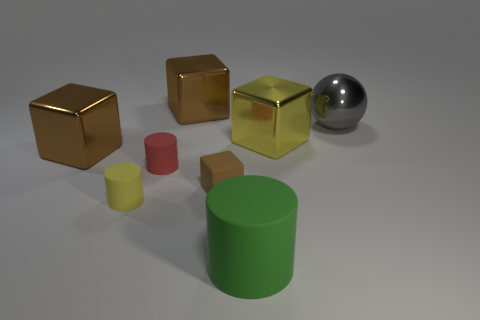There is a red matte object; what number of brown metallic blocks are in front of it?
Offer a very short reply. 0. Does the big brown block behind the ball have the same material as the big yellow cube?
Give a very brief answer. Yes. What number of other things are the same shape as the tiny brown matte thing?
Ensure brevity in your answer.  3. There is a brown metal object that is in front of the brown object that is behind the gray metallic object; how many big brown shiny objects are behind it?
Your answer should be compact. 1. What is the color of the shiny cube behind the gray sphere?
Offer a terse response. Brown. There is a block on the left side of the small red rubber thing; is it the same color as the big matte cylinder?
Make the answer very short. No. What size is the yellow rubber thing that is the same shape as the green rubber object?
Your answer should be very brief. Small. Is there anything else that is the same size as the sphere?
Provide a short and direct response. Yes. There is a big brown thing that is left of the brown block that is behind the large brown object to the left of the yellow matte object; what is its material?
Ensure brevity in your answer.  Metal. Are there more gray metal spheres that are in front of the small brown rubber object than brown rubber blocks that are in front of the small yellow rubber cylinder?
Offer a terse response. No. 